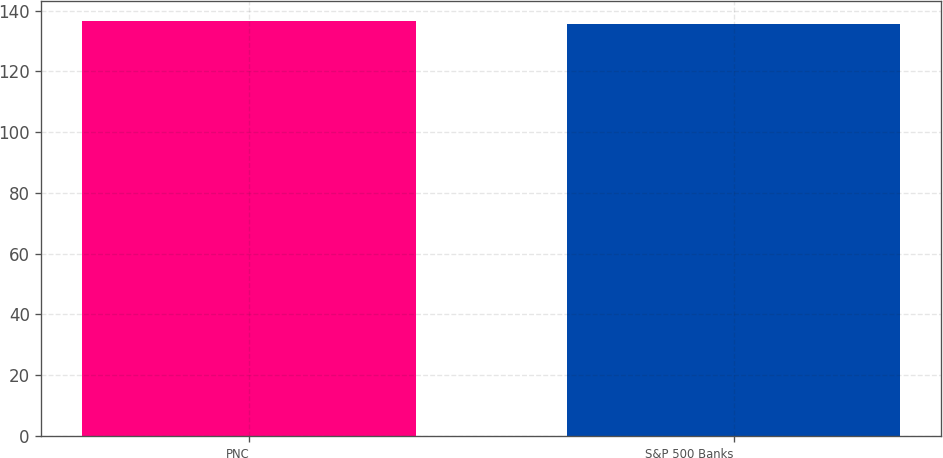Convert chart to OTSL. <chart><loc_0><loc_0><loc_500><loc_500><bar_chart><fcel>PNC<fcel>S&P 500 Banks<nl><fcel>136.45<fcel>135.72<nl></chart> 